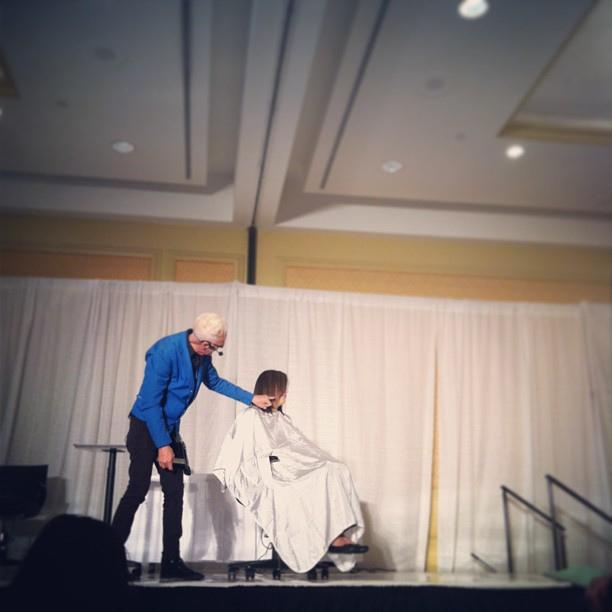What is the woman receiving on the stage? Please explain your reasoning. haircut. The man is a stylist and cutting her hair to show how to do it on stage. 